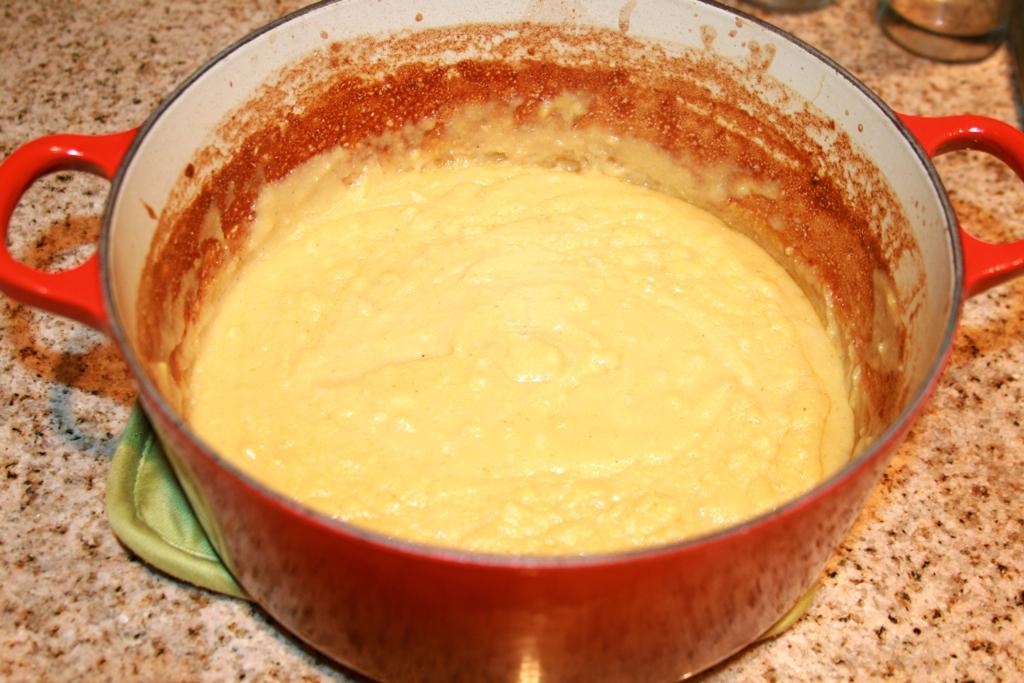Describe this image in one or two sentences. In this image I can see the food in the bowl and the food is in yellow color and the bowl is on the tray and the tray is on the brown color surface. 